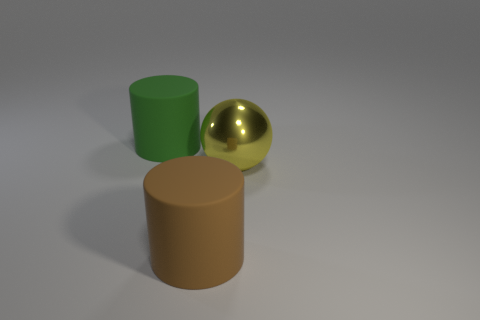Subtract all purple cylinders. Subtract all blue spheres. How many cylinders are left? 2 Add 3 large green cylinders. How many objects exist? 6 Subtract all balls. How many objects are left? 2 Add 1 small red rubber things. How many small red rubber things exist? 1 Subtract 0 gray cubes. How many objects are left? 3 Subtract all small blue metallic cylinders. Subtract all big metal balls. How many objects are left? 2 Add 1 matte cylinders. How many matte cylinders are left? 3 